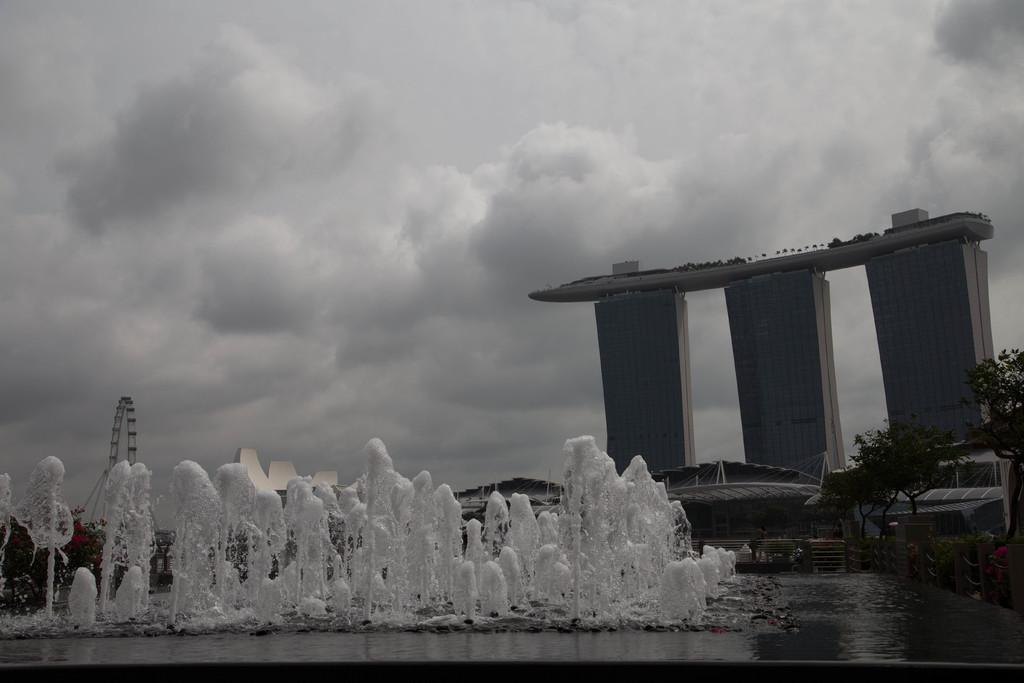What natural feature is located on the left side of the image? There is a waterfall on the left side of the image. What man-made structure is on the right side of the image? There is a building on the right side of the image. What can be seen in the background of the image? The sky is visible in the background of the image. How many ducks are swimming in the waterfall in the image? There are no ducks present in the image; it features a waterfall and a building. What type of home is visible in the image? There is no home visible in the image; it features a waterfall and a building. 